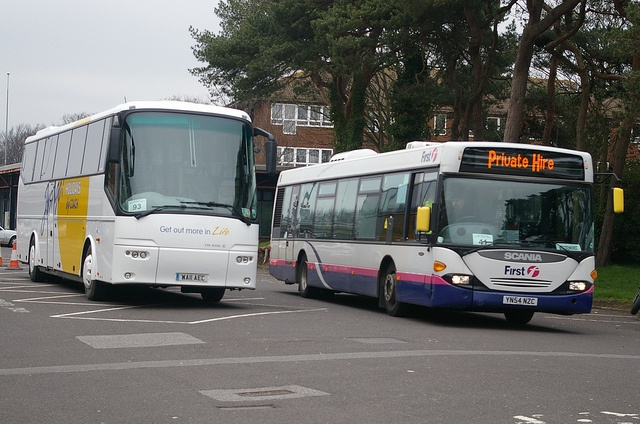Describe the objects in this image and their specific colors. I can see bus in lightgray, black, gray, and darkgray tones, bus in lightgray, darkgray, black, and gray tones, and car in lightgray, darkgray, gray, and black tones in this image. 